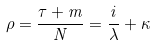Convert formula to latex. <formula><loc_0><loc_0><loc_500><loc_500>\rho = \frac { \tau + m } { N } = \frac { i } { \lambda } + \kappa</formula> 